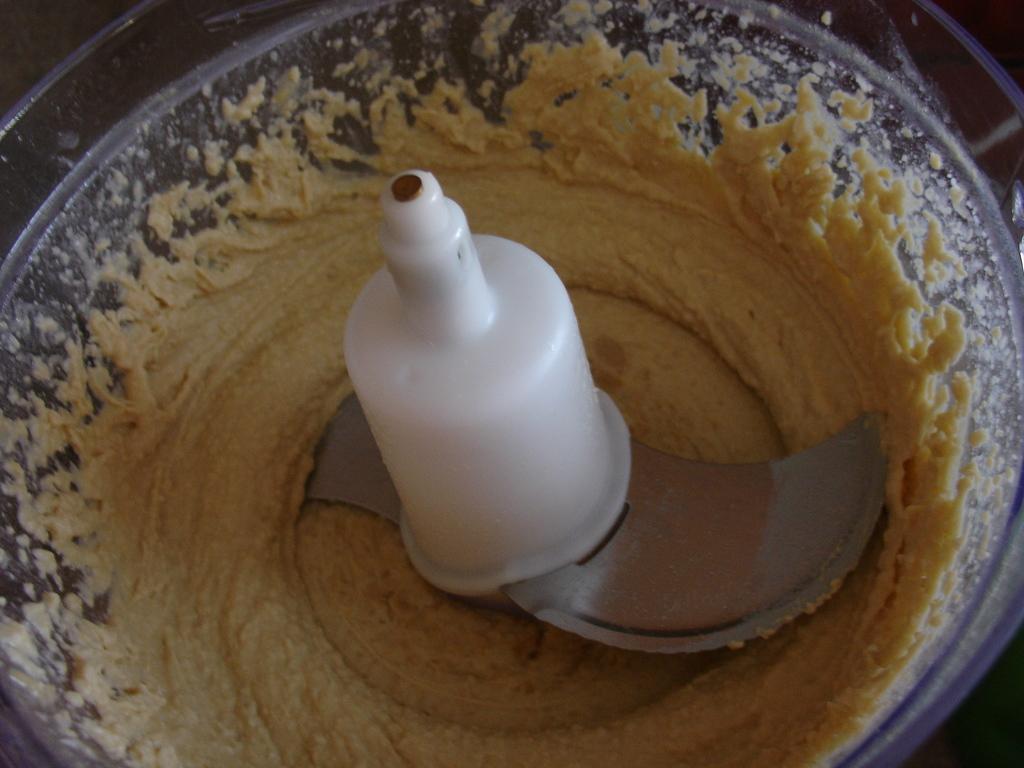How would you summarize this image in a sentence or two? In this image I can see a grinder jar which consists of paste in it. 